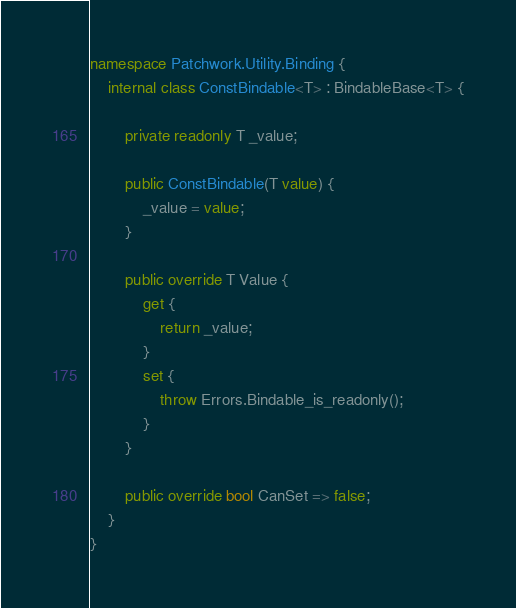Convert code to text. <code><loc_0><loc_0><loc_500><loc_500><_C#_>namespace Patchwork.Utility.Binding {
	internal class ConstBindable<T> : BindableBase<T> {

		private readonly T _value;

		public ConstBindable(T value) {
			_value = value;
		}

		public override T Value {
			get {
				return _value;
			}
			set {
				throw Errors.Bindable_is_readonly();
			}
		}

		public override bool CanSet => false;
	}
}</code> 